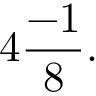Convert formula to latex. <formula><loc_0><loc_0><loc_500><loc_500>4 { \frac { - 1 } { 8 } } .</formula> 